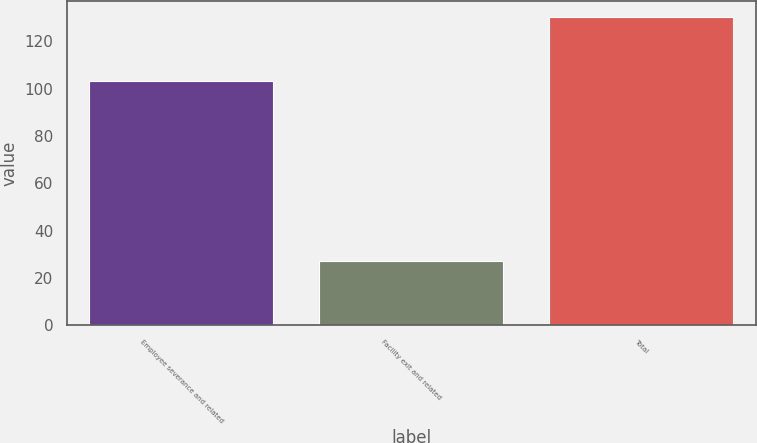Convert chart. <chart><loc_0><loc_0><loc_500><loc_500><bar_chart><fcel>Employee severance and related<fcel>Facility exit and related<fcel>Total<nl><fcel>103.3<fcel>27.1<fcel>130.4<nl></chart> 